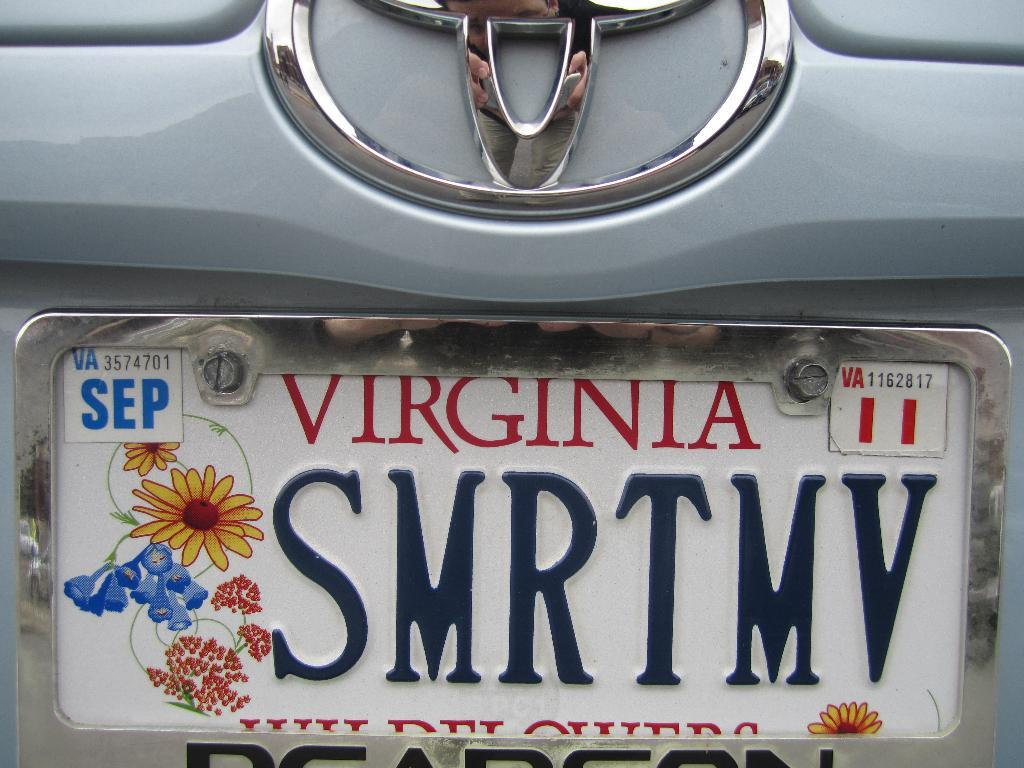<image>
Create a compact narrative representing the image presented. A Virginia license plate with the letters SMRTMV on it 